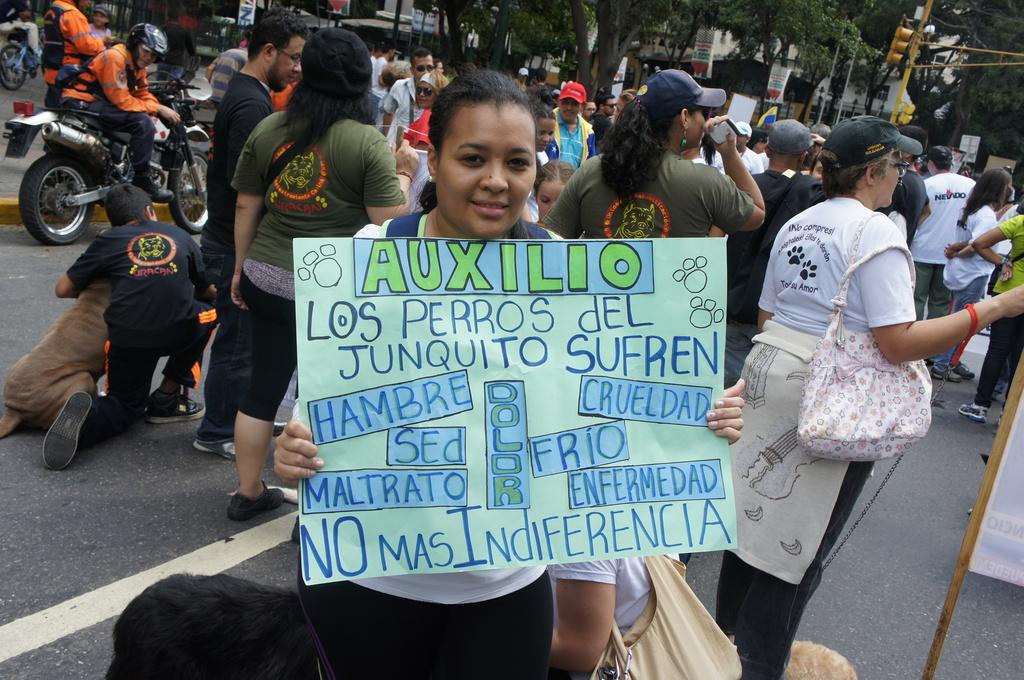What is the woman in the image holding? The woman is holding a banner in the image. What can be seen in the background of the image? There is a large crowd in the background of the image. What might be happening in the scene? The scene appears to be a strike or protest. What vehicle is visible in the left side corner of the image? There is a motorcycle in the left side corner of the image. What type of volleyball game is happening in the background of the image? There is no volleyball game present in the image; it depicts a protest or strike scene. Who is the woman's partner in the image? The image does not show any partners or relationships between the people present. 